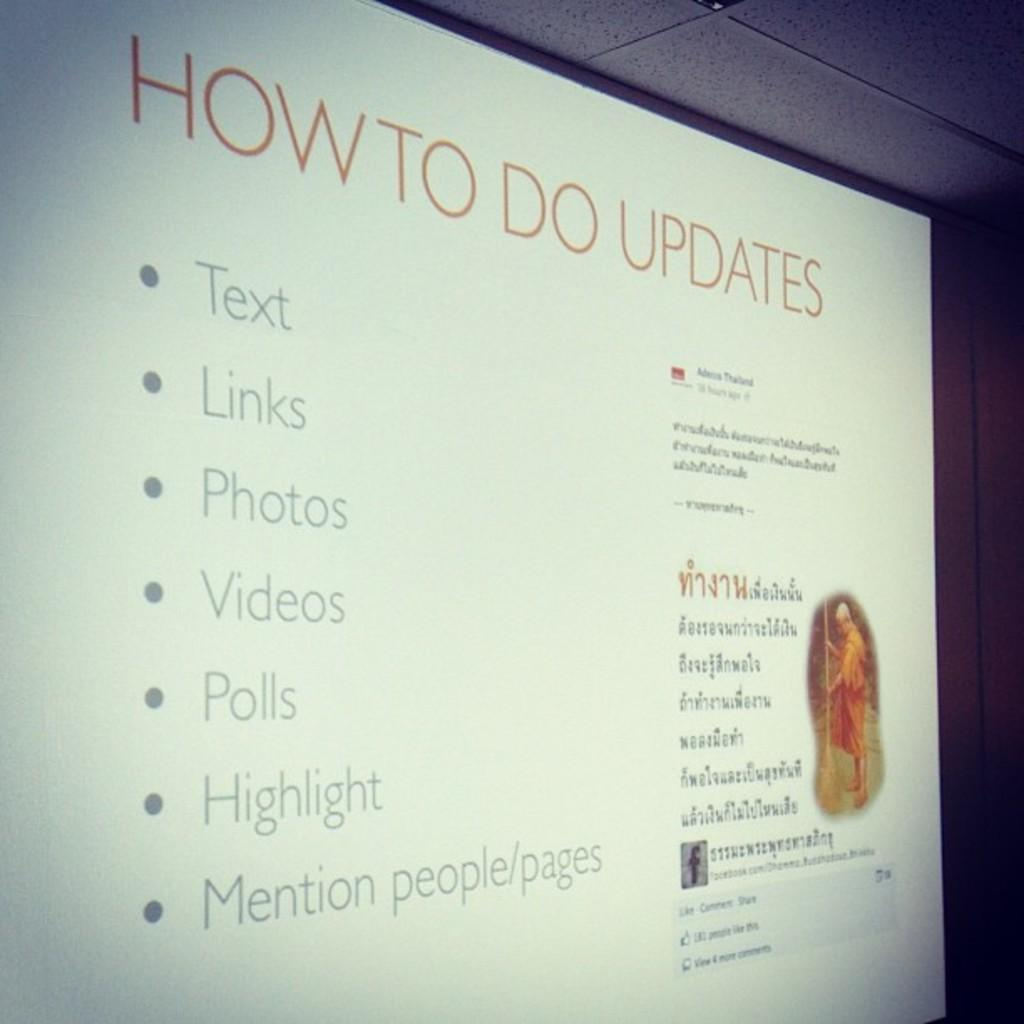<image>
Relay a brief, clear account of the picture shown. a screen that has the word updates on it 